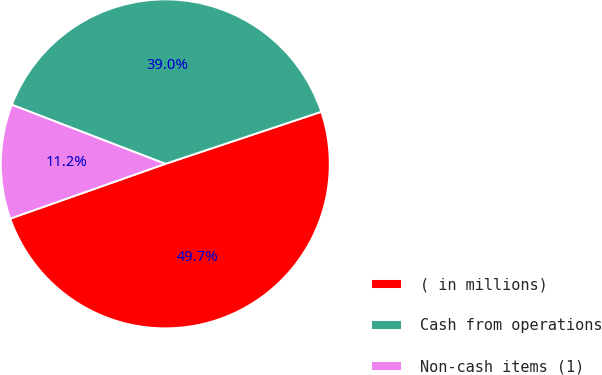<chart> <loc_0><loc_0><loc_500><loc_500><pie_chart><fcel>( in millions)<fcel>Cash from operations<fcel>Non-cash items (1)<nl><fcel>49.73%<fcel>39.02%<fcel>11.25%<nl></chart> 